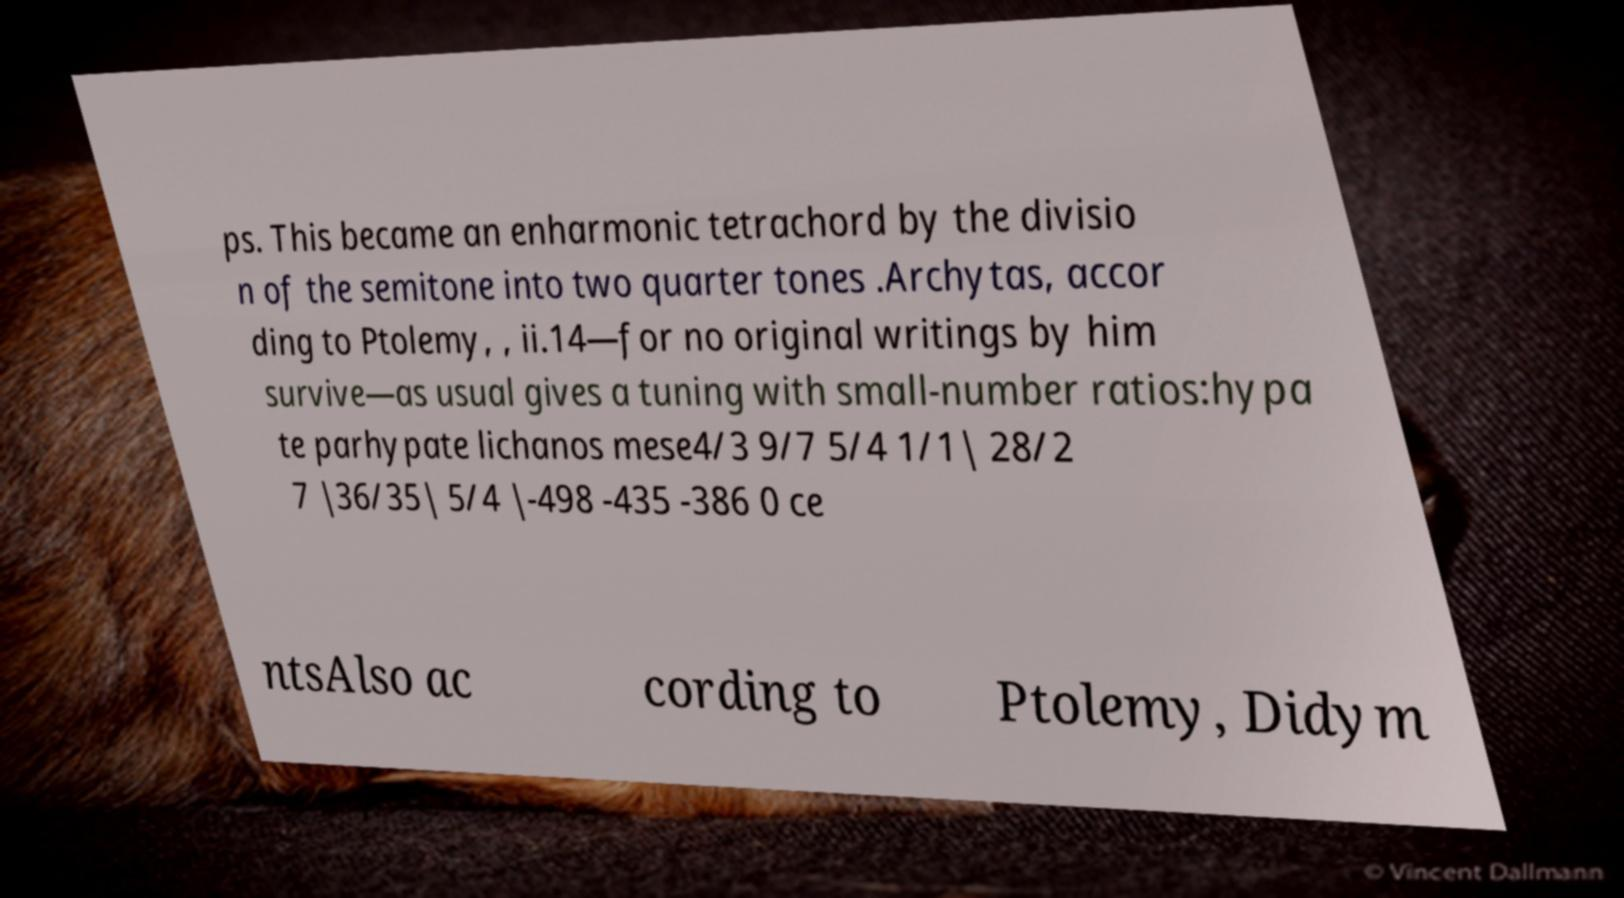What messages or text are displayed in this image? I need them in a readable, typed format. ps. This became an enharmonic tetrachord by the divisio n of the semitone into two quarter tones .Archytas, accor ding to Ptolemy, , ii.14—for no original writings by him survive—as usual gives a tuning with small-number ratios:hypa te parhypate lichanos mese4/3 9/7 5/4 1/1| 28/2 7 |36/35| 5/4 |-498 -435 -386 0 ce ntsAlso ac cording to Ptolemy, Didym 